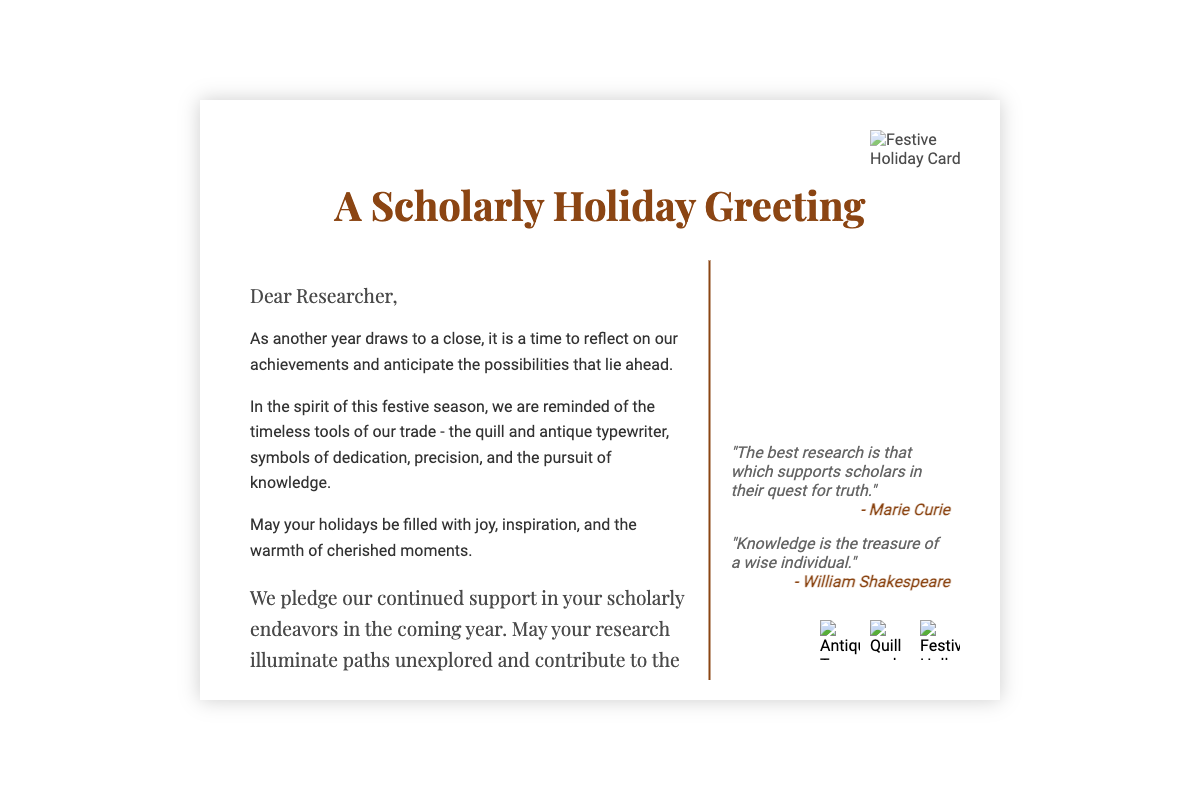What is the title of the card? The title is prominently displayed at the top of the card, stating the card's purpose.
Answer: A Scholarly Holiday Greeting Who is the card addressed to? The salutation in the message section addresses the recipient directly, indicating who the card is meant for.
Answer: Researcher What decorative imagery is featured on the card? Antique typewriters and quills are mentioned in the content, symbolizing the scholarly theme.
Answer: Antique typewriter and quills Which two quotes are included in the card? The quotes from notable figures are explicitly listed in the content, providing wisdom related to research and knowledge.
Answer: "The best research is that which supports scholars in their quest for truth." and "Knowledge is the treasure of a wise individual." What pledge is made regarding support in the coming year? The closing statement in the message mentions a commitment to continued support for the recipient's endeavors.
Answer: Continued support in your scholarly endeavors How is the tone of the message described? The overall message portrays a warm, motivational, and festive tone.
Answer: Warm and festive What type of imagery is used in the background? The background consists of a subtle texture that gives a scholarly feel to the card.
Answer: Soft parchment paper texture What color is used for the title text? The title's color is specified, aiding in the festive and scholarly aesthetic.
Answer: #8B4513 